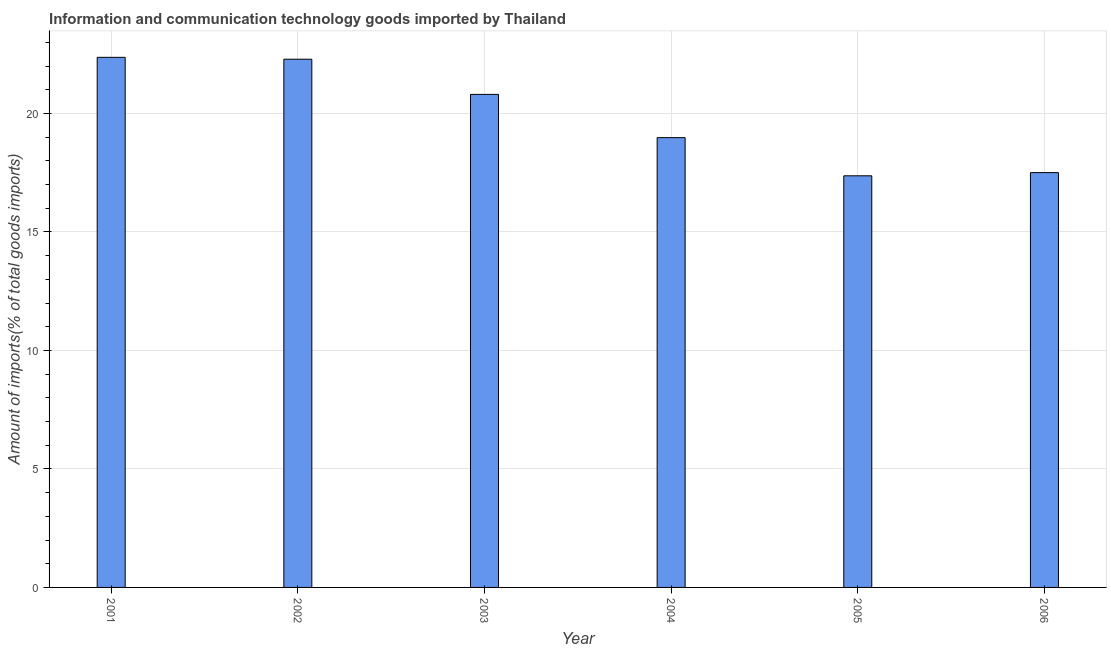Does the graph contain grids?
Offer a very short reply. Yes. What is the title of the graph?
Provide a short and direct response. Information and communication technology goods imported by Thailand. What is the label or title of the X-axis?
Offer a terse response. Year. What is the label or title of the Y-axis?
Ensure brevity in your answer.  Amount of imports(% of total goods imports). What is the amount of ict goods imports in 2002?
Keep it short and to the point. 22.29. Across all years, what is the maximum amount of ict goods imports?
Provide a succinct answer. 22.37. Across all years, what is the minimum amount of ict goods imports?
Keep it short and to the point. 17.37. In which year was the amount of ict goods imports minimum?
Provide a succinct answer. 2005. What is the sum of the amount of ict goods imports?
Make the answer very short. 119.33. What is the difference between the amount of ict goods imports in 2004 and 2005?
Your answer should be very brief. 1.61. What is the average amount of ict goods imports per year?
Keep it short and to the point. 19.89. What is the median amount of ict goods imports?
Give a very brief answer. 19.89. Do a majority of the years between 2006 and 2005 (inclusive) have amount of ict goods imports greater than 15 %?
Your answer should be very brief. No. What is the ratio of the amount of ict goods imports in 2001 to that in 2003?
Ensure brevity in your answer.  1.07. Is the amount of ict goods imports in 2002 less than that in 2004?
Your answer should be very brief. No. Is the difference between the amount of ict goods imports in 2002 and 2004 greater than the difference between any two years?
Offer a very short reply. No. What is the difference between the highest and the second highest amount of ict goods imports?
Ensure brevity in your answer.  0.08. Is the sum of the amount of ict goods imports in 2002 and 2004 greater than the maximum amount of ict goods imports across all years?
Make the answer very short. Yes. In how many years, is the amount of ict goods imports greater than the average amount of ict goods imports taken over all years?
Your response must be concise. 3. How many bars are there?
Keep it short and to the point. 6. Are all the bars in the graph horizontal?
Provide a short and direct response. No. What is the difference between two consecutive major ticks on the Y-axis?
Provide a short and direct response. 5. Are the values on the major ticks of Y-axis written in scientific E-notation?
Make the answer very short. No. What is the Amount of imports(% of total goods imports) of 2001?
Provide a short and direct response. 22.37. What is the Amount of imports(% of total goods imports) in 2002?
Make the answer very short. 22.29. What is the Amount of imports(% of total goods imports) in 2003?
Give a very brief answer. 20.81. What is the Amount of imports(% of total goods imports) in 2004?
Keep it short and to the point. 18.98. What is the Amount of imports(% of total goods imports) of 2005?
Offer a terse response. 17.37. What is the Amount of imports(% of total goods imports) of 2006?
Your answer should be compact. 17.51. What is the difference between the Amount of imports(% of total goods imports) in 2001 and 2002?
Make the answer very short. 0.08. What is the difference between the Amount of imports(% of total goods imports) in 2001 and 2003?
Keep it short and to the point. 1.56. What is the difference between the Amount of imports(% of total goods imports) in 2001 and 2004?
Give a very brief answer. 3.39. What is the difference between the Amount of imports(% of total goods imports) in 2001 and 2005?
Your answer should be compact. 5. What is the difference between the Amount of imports(% of total goods imports) in 2001 and 2006?
Give a very brief answer. 4.87. What is the difference between the Amount of imports(% of total goods imports) in 2002 and 2003?
Give a very brief answer. 1.48. What is the difference between the Amount of imports(% of total goods imports) in 2002 and 2004?
Ensure brevity in your answer.  3.31. What is the difference between the Amount of imports(% of total goods imports) in 2002 and 2005?
Offer a very short reply. 4.92. What is the difference between the Amount of imports(% of total goods imports) in 2002 and 2006?
Offer a terse response. 4.79. What is the difference between the Amount of imports(% of total goods imports) in 2003 and 2004?
Give a very brief answer. 1.83. What is the difference between the Amount of imports(% of total goods imports) in 2003 and 2005?
Give a very brief answer. 3.44. What is the difference between the Amount of imports(% of total goods imports) in 2003 and 2006?
Offer a very short reply. 3.3. What is the difference between the Amount of imports(% of total goods imports) in 2004 and 2005?
Offer a very short reply. 1.61. What is the difference between the Amount of imports(% of total goods imports) in 2004 and 2006?
Keep it short and to the point. 1.48. What is the difference between the Amount of imports(% of total goods imports) in 2005 and 2006?
Give a very brief answer. -0.13. What is the ratio of the Amount of imports(% of total goods imports) in 2001 to that in 2002?
Give a very brief answer. 1. What is the ratio of the Amount of imports(% of total goods imports) in 2001 to that in 2003?
Provide a short and direct response. 1.07. What is the ratio of the Amount of imports(% of total goods imports) in 2001 to that in 2004?
Keep it short and to the point. 1.18. What is the ratio of the Amount of imports(% of total goods imports) in 2001 to that in 2005?
Keep it short and to the point. 1.29. What is the ratio of the Amount of imports(% of total goods imports) in 2001 to that in 2006?
Ensure brevity in your answer.  1.28. What is the ratio of the Amount of imports(% of total goods imports) in 2002 to that in 2003?
Give a very brief answer. 1.07. What is the ratio of the Amount of imports(% of total goods imports) in 2002 to that in 2004?
Provide a succinct answer. 1.17. What is the ratio of the Amount of imports(% of total goods imports) in 2002 to that in 2005?
Give a very brief answer. 1.28. What is the ratio of the Amount of imports(% of total goods imports) in 2002 to that in 2006?
Keep it short and to the point. 1.27. What is the ratio of the Amount of imports(% of total goods imports) in 2003 to that in 2004?
Keep it short and to the point. 1.1. What is the ratio of the Amount of imports(% of total goods imports) in 2003 to that in 2005?
Your answer should be very brief. 1.2. What is the ratio of the Amount of imports(% of total goods imports) in 2003 to that in 2006?
Your response must be concise. 1.19. What is the ratio of the Amount of imports(% of total goods imports) in 2004 to that in 2005?
Offer a very short reply. 1.09. What is the ratio of the Amount of imports(% of total goods imports) in 2004 to that in 2006?
Your answer should be very brief. 1.08. 